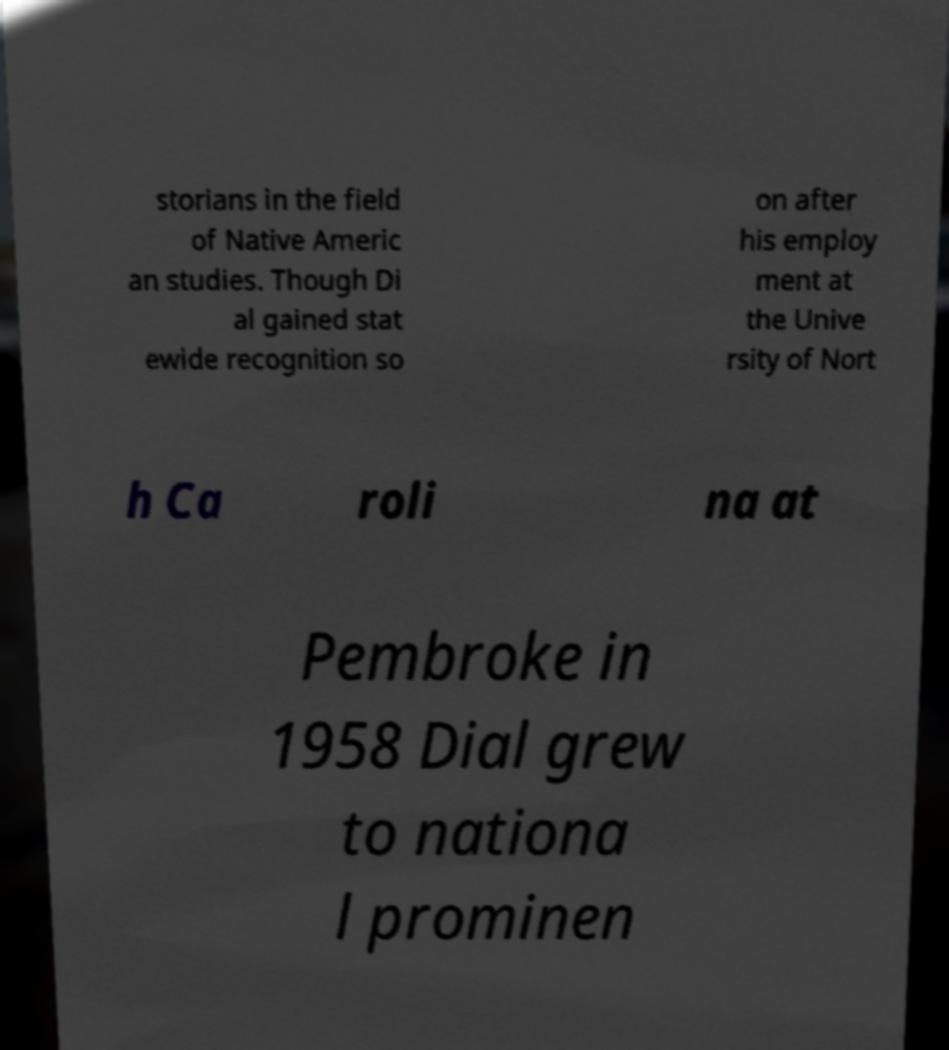Could you assist in decoding the text presented in this image and type it out clearly? storians in the field of Native Americ an studies. Though Di al gained stat ewide recognition so on after his employ ment at the Unive rsity of Nort h Ca roli na at Pembroke in 1958 Dial grew to nationa l prominen 